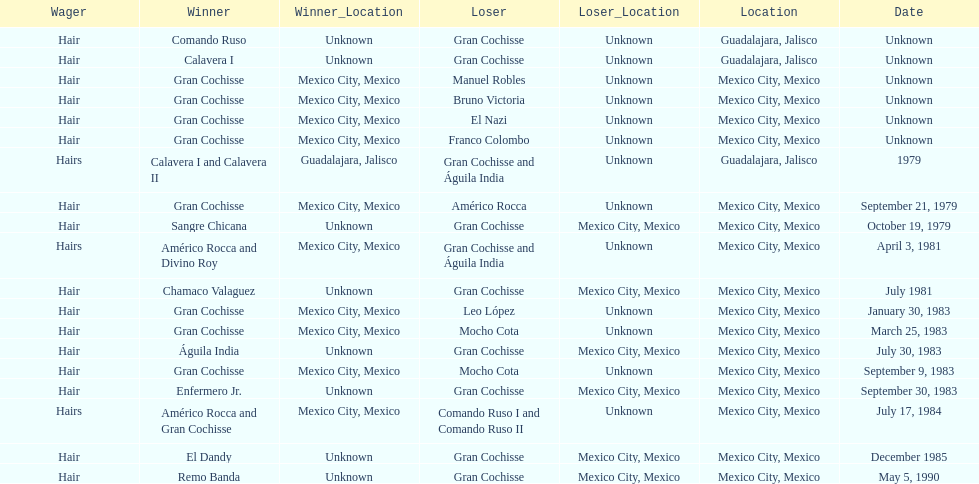How many winners were there before bruno victoria lost? 3. Would you mind parsing the complete table? {'header': ['Wager', 'Winner', 'Winner_Location', 'Loser', 'Loser_Location', 'Location', 'Date'], 'rows': [['Hair', 'Comando Ruso', 'Unknown', 'Gran Cochisse', 'Unknown', 'Guadalajara, Jalisco', 'Unknown'], ['Hair', 'Calavera I', 'Unknown', 'Gran Cochisse', 'Unknown', 'Guadalajara, Jalisco', 'Unknown'], ['Hair', 'Gran Cochisse', 'Mexico City, Mexico', 'Manuel Robles', 'Unknown', 'Mexico City, Mexico', 'Unknown'], ['Hair', 'Gran Cochisse', 'Mexico City, Mexico', 'Bruno Victoria', 'Unknown', 'Mexico City, Mexico', 'Unknown'], ['Hair', 'Gran Cochisse', 'Mexico City, Mexico', 'El Nazi', 'Unknown', 'Mexico City, Mexico', 'Unknown'], ['Hair', 'Gran Cochisse', 'Mexico City, Mexico', 'Franco Colombo', 'Unknown', 'Mexico City, Mexico', 'Unknown'], ['Hairs', 'Calavera I and Calavera II', 'Guadalajara, Jalisco', 'Gran Cochisse and Águila India', 'Unknown', 'Guadalajara, Jalisco', '1979'], ['Hair', 'Gran Cochisse', 'Mexico City, Mexico', 'Américo Rocca', 'Unknown', 'Mexico City, Mexico', 'September 21, 1979'], ['Hair', 'Sangre Chicana', 'Unknown', 'Gran Cochisse', 'Mexico City, Mexico', 'Mexico City, Mexico', 'October 19, 1979'], ['Hairs', 'Américo Rocca and Divino Roy', 'Mexico City, Mexico', 'Gran Cochisse and Águila India', 'Unknown', 'Mexico City, Mexico', 'April 3, 1981'], ['Hair', 'Chamaco Valaguez', 'Unknown', 'Gran Cochisse', 'Mexico City, Mexico', 'Mexico City, Mexico', 'July 1981'], ['Hair', 'Gran Cochisse', 'Mexico City, Mexico', 'Leo López', 'Unknown', 'Mexico City, Mexico', 'January 30, 1983'], ['Hair', 'Gran Cochisse', 'Mexico City, Mexico', 'Mocho Cota', 'Unknown', 'Mexico City, Mexico', 'March 25, 1983'], ['Hair', 'Águila India', 'Unknown', 'Gran Cochisse', 'Mexico City, Mexico', 'Mexico City, Mexico', 'July 30, 1983'], ['Hair', 'Gran Cochisse', 'Mexico City, Mexico', 'Mocho Cota', 'Unknown', 'Mexico City, Mexico', 'September 9, 1983'], ['Hair', 'Enfermero Jr.', 'Unknown', 'Gran Cochisse', 'Mexico City, Mexico', 'Mexico City, Mexico', 'September 30, 1983'], ['Hairs', 'Américo Rocca and Gran Cochisse', 'Mexico City, Mexico', 'Comando Ruso I and Comando Ruso II', 'Unknown', 'Mexico City, Mexico', 'July 17, 1984'], ['Hair', 'El Dandy', 'Unknown', 'Gran Cochisse', 'Mexico City, Mexico', 'Mexico City, Mexico', 'December 1985'], ['Hair', 'Remo Banda', 'Unknown', 'Gran Cochisse', 'Mexico City, Mexico', 'Mexico City, Mexico', 'May 5, 1990']]} 